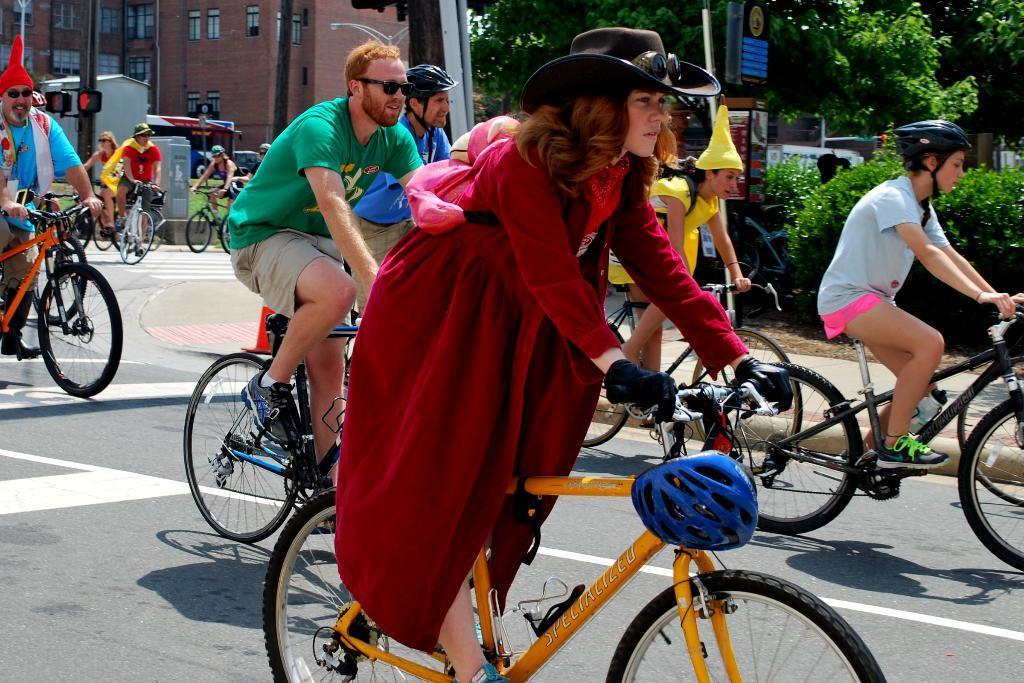Describe this image in one or two sentences. In this image I can see few people are cycling their cycles. I can also see few of them are wearing helmets. In the background I can see few trees, a building and few more people with cycles. 